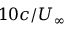Convert formula to latex. <formula><loc_0><loc_0><loc_500><loc_500>1 0 c / U _ { \infty }</formula> 